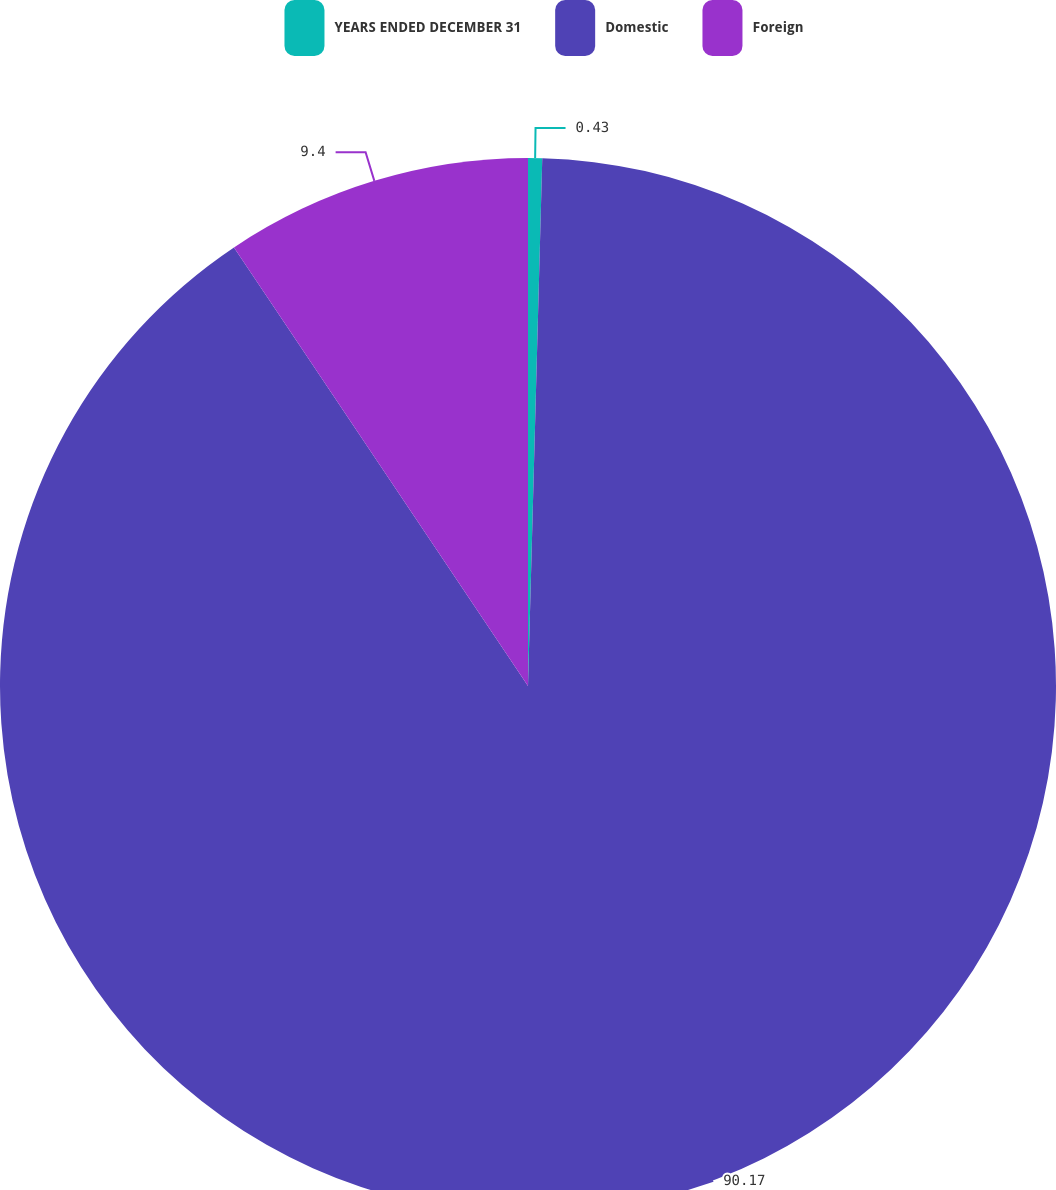<chart> <loc_0><loc_0><loc_500><loc_500><pie_chart><fcel>YEARS ENDED DECEMBER 31<fcel>Domestic<fcel>Foreign<nl><fcel>0.43%<fcel>90.17%<fcel>9.4%<nl></chart> 